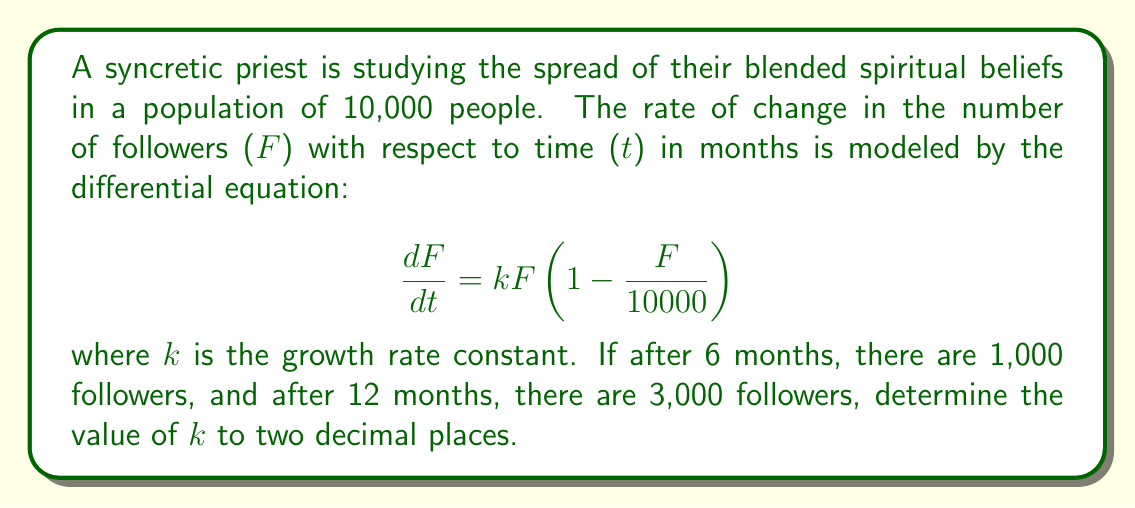Can you solve this math problem? 1. We can solve this problem using the logistic growth model. The general solution for the logistic equation is:

   $$F(t) = \frac{K}{1 + (\frac{K}{F_0} - 1)e^{-kt}}$$

   where K is the carrying capacity (10,000 in this case) and $F_0$ is the initial number of followers.

2. We don't know $F_0$, but we can use the two given data points to set up a system of equations:

   $$1000 = \frac{10000}{1 + (10000/F_0 - 1)e^{-6k}}$$
   $$3000 = \frac{10000}{1 + (10000/F_0 - 1)e^{-12k}}$$

3. Dividing the second equation by the first:

   $$3 = \frac{1 + (10000/F_0 - 1)e^{-6k}}{1 + (10000/F_0 - 1)e^{-12k}}$$

4. Let $A = 10000/F_0 - 1$, then:

   $$3 = \frac{1 + Ae^{-6k}}{1 + Ae^{-12k}}$$

5. Cross-multiply:

   $$3 + 3Ae^{-12k} = 1 + Ae^{-6k}$$

6. Simplify:

   $$2 = Ae^{-6k} - 3Ae^{-12k}$$
   $$2 = A(e^{-6k} - 3e^{-12k})$$

7. Let $x = e^{-6k}$, then:

   $$2 = A(x - 3x^2)$$

8. Solve for A:

   $$A = \frac{2}{x - 3x^2}$$

9. Substitute this back into the equation from step 4:

   $$3 = \frac{1 + \frac{2}{x - 3x^2}x}{1 + \frac{2}{x - 3x^2}x^2}$$

10. Simplify and solve for x numerically (e.g., using Newton's method). This gives:

    $$x \approx 0.5916$$

11. Recall that $x = e^{-6k}$, so:

    $$k = -\frac{1}{6}\ln(0.5916) \approx 0.0874$$

12. Rounding to two decimal places gives k = 0.09.
Answer: k = 0.09 